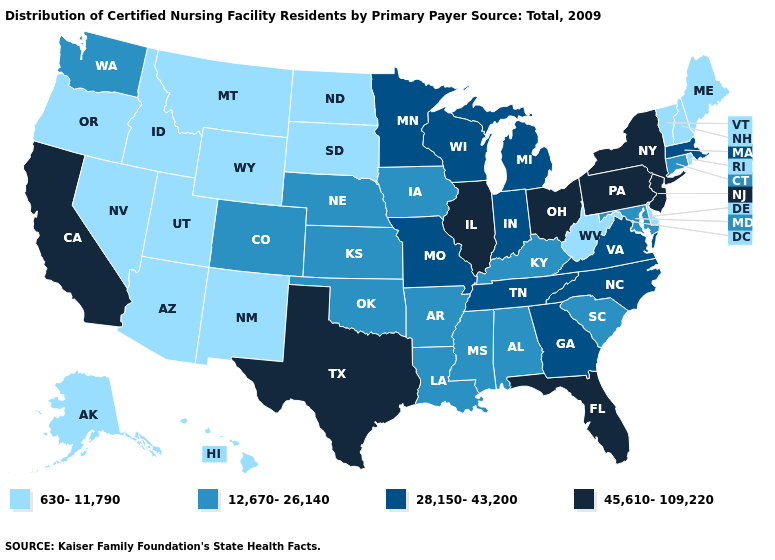Among the states that border Nevada , does California have the highest value?
Answer briefly. Yes. What is the value of Colorado?
Answer briefly. 12,670-26,140. Which states have the lowest value in the USA?
Short answer required. Alaska, Arizona, Delaware, Hawaii, Idaho, Maine, Montana, Nevada, New Hampshire, New Mexico, North Dakota, Oregon, Rhode Island, South Dakota, Utah, Vermont, West Virginia, Wyoming. What is the value of Oregon?
Be succinct. 630-11,790. Name the states that have a value in the range 45,610-109,220?
Keep it brief. California, Florida, Illinois, New Jersey, New York, Ohio, Pennsylvania, Texas. Does Nevada have the same value as South Dakota?
Answer briefly. Yes. Name the states that have a value in the range 630-11,790?
Concise answer only. Alaska, Arizona, Delaware, Hawaii, Idaho, Maine, Montana, Nevada, New Hampshire, New Mexico, North Dakota, Oregon, Rhode Island, South Dakota, Utah, Vermont, West Virginia, Wyoming. Which states have the lowest value in the MidWest?
Write a very short answer. North Dakota, South Dakota. Name the states that have a value in the range 630-11,790?
Be succinct. Alaska, Arizona, Delaware, Hawaii, Idaho, Maine, Montana, Nevada, New Hampshire, New Mexico, North Dakota, Oregon, Rhode Island, South Dakota, Utah, Vermont, West Virginia, Wyoming. Name the states that have a value in the range 630-11,790?
Give a very brief answer. Alaska, Arizona, Delaware, Hawaii, Idaho, Maine, Montana, Nevada, New Hampshire, New Mexico, North Dakota, Oregon, Rhode Island, South Dakota, Utah, Vermont, West Virginia, Wyoming. Does Alaska have the lowest value in the West?
Quick response, please. Yes. What is the value of North Carolina?
Quick response, please. 28,150-43,200. Name the states that have a value in the range 28,150-43,200?
Short answer required. Georgia, Indiana, Massachusetts, Michigan, Minnesota, Missouri, North Carolina, Tennessee, Virginia, Wisconsin. Does Rhode Island have the lowest value in the Northeast?
Answer briefly. Yes. What is the lowest value in the South?
Short answer required. 630-11,790. 